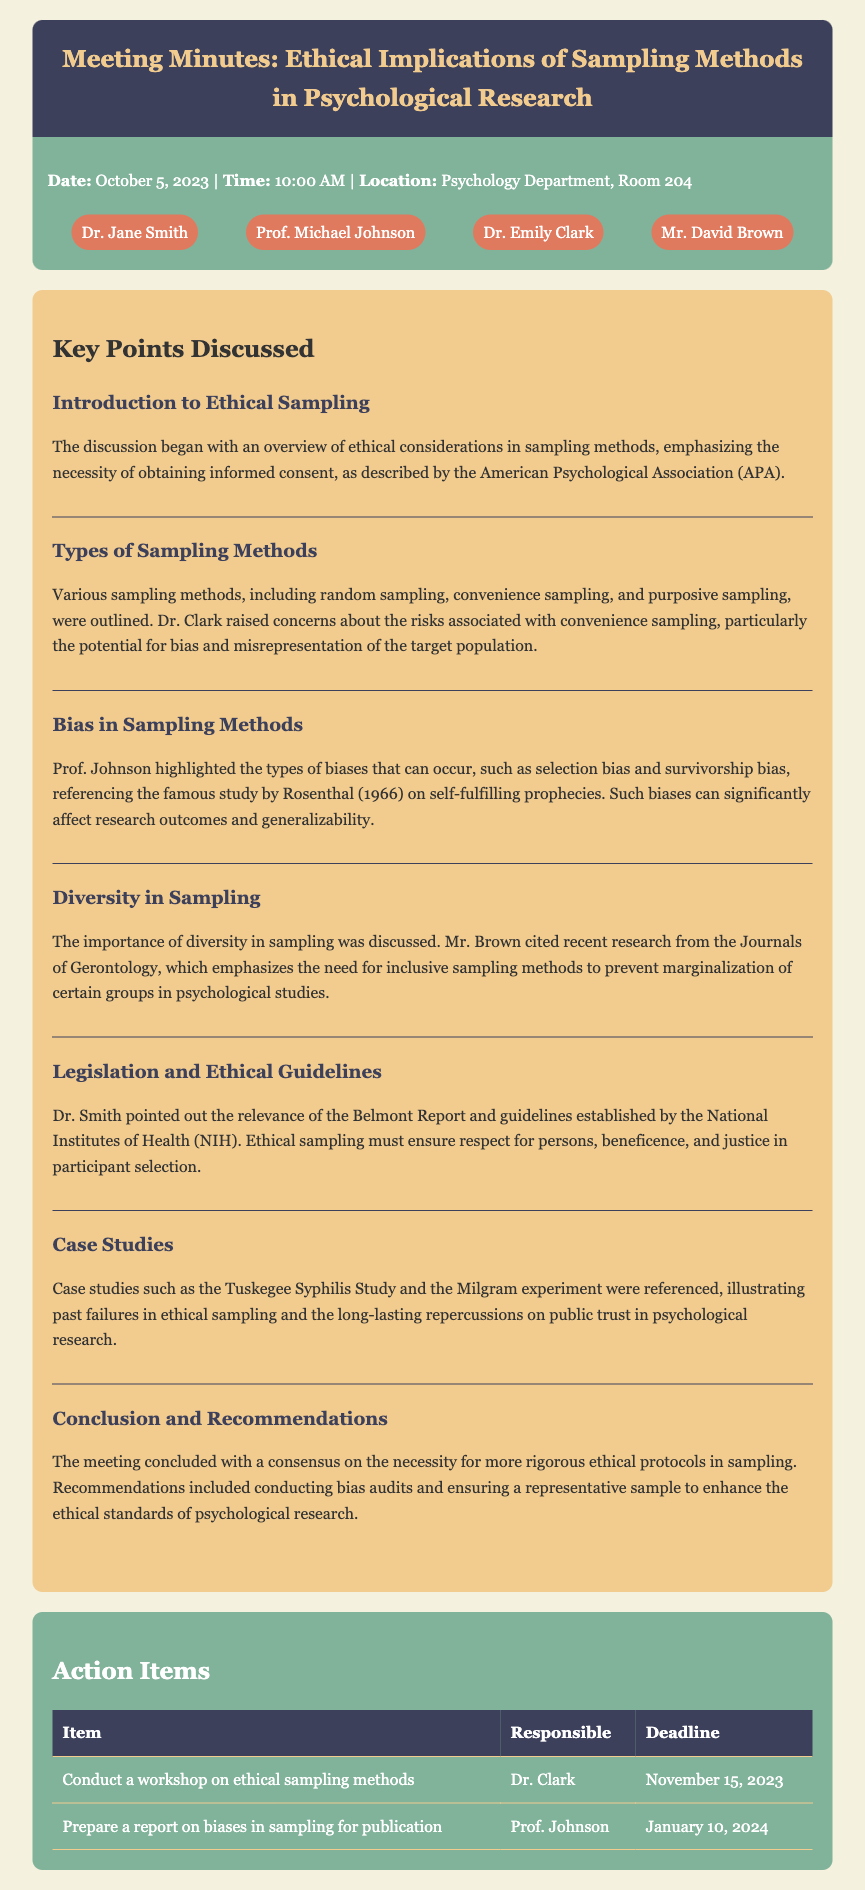What is the date of the meeting? The date of the meeting is clearly stated in the meta-info section of the document.
Answer: October 5, 2023 Who highlighted the types of biases that can occur in sampling methods? This information is found in the key points section, under "Bias in Sampling Methods."
Answer: Prof. Johnson What is one of the case studies referenced during the meeting? The meeting minutes list specific case studies in the section discussing past failures in ethical sampling.
Answer: Tuskegee Syphilis Study What was a recommendation concluded in the meeting? The recommendations are discussed at the end of the key points and highlight necessary actions for ethical standards.
Answer: Conducting bias audits Who is responsible for conducting a workshop on ethical sampling methods? The action items table specifies who is responsible for each task.
Answer: Dr. Clark What does the Belmont Report emphasize according to Dr. Smith? The points discussed in the key points section determine the ethical principles related to participant selection.
Answer: Respect for persons, beneficence, and justice 